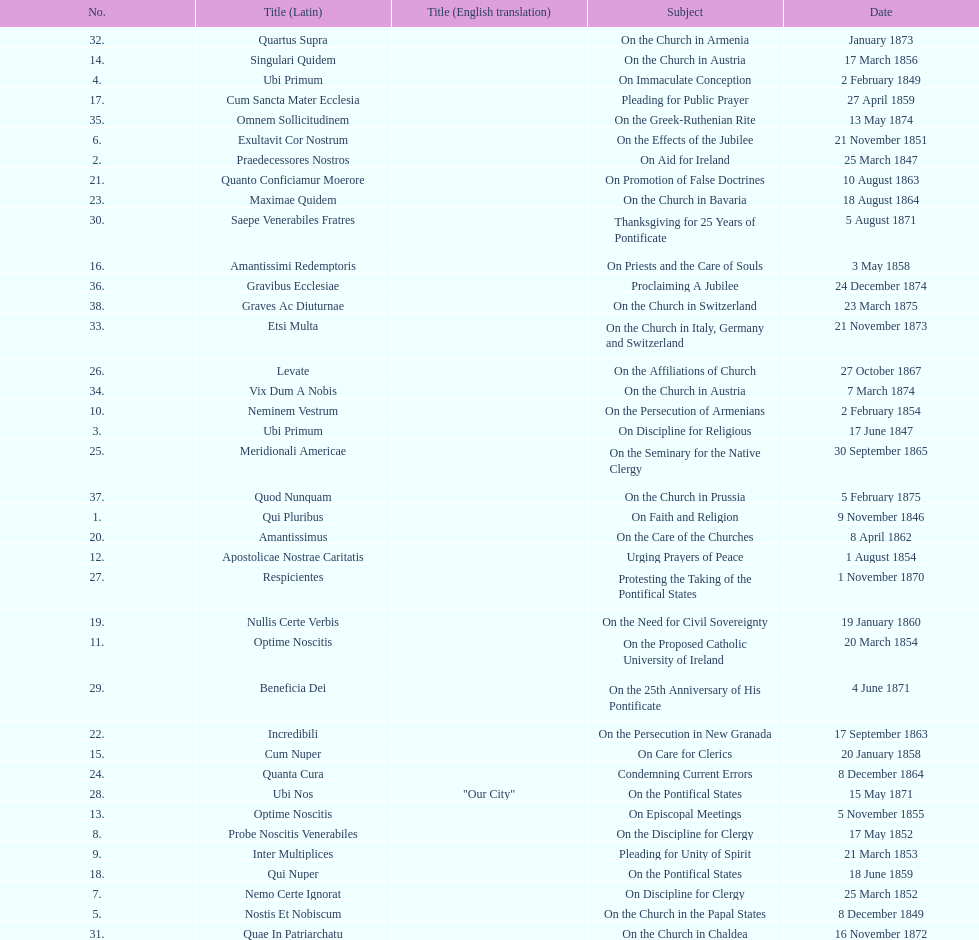How many encyclicals were issued between august 15, 1854 and october 26, 1867? 13. 